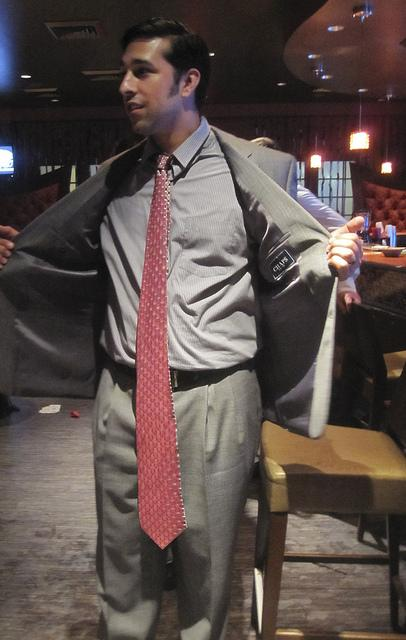What clothing item is most strangely fitting on this man? Please explain your reasoning. necktie. It is much longer than it should be 